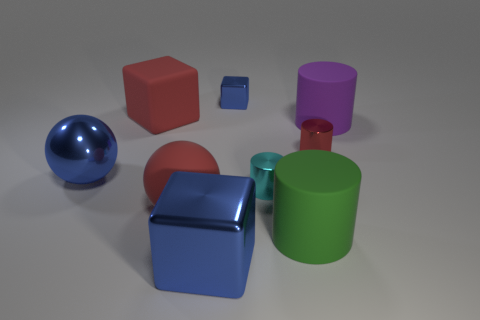What number of blocks are red metal things or tiny blue shiny things?
Offer a very short reply. 1. What number of green matte cylinders are right of the small blue metallic cube that is behind the small cyan metal thing?
Keep it short and to the point. 1. Is the big purple thing made of the same material as the blue ball?
Your response must be concise. No. What size is the sphere that is the same color as the matte block?
Your answer should be very brief. Large. Are there any large cubes that have the same material as the big purple cylinder?
Make the answer very short. Yes. What is the color of the block in front of the large purple cylinder on the right side of the matte cylinder that is in front of the big blue sphere?
Provide a short and direct response. Blue. How many blue things are either matte spheres or tiny shiny cylinders?
Keep it short and to the point. 0. How many large rubber things are the same shape as the cyan metal thing?
Give a very brief answer. 2. There is a blue shiny object that is the same size as the cyan cylinder; what shape is it?
Offer a terse response. Cube. There is a red rubber sphere; are there any blue blocks in front of it?
Offer a very short reply. Yes. 